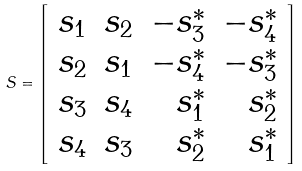Convert formula to latex. <formula><loc_0><loc_0><loc_500><loc_500>S = \left [ \begin{array} { c c r r } s _ { 1 } & s _ { 2 } & - s _ { 3 } ^ { * } & - s _ { 4 } ^ { * } \\ s _ { 2 } & s _ { 1 } & - s _ { 4 } ^ { * } & - s _ { 3 } ^ { * } \\ s _ { 3 } & s _ { 4 } & s _ { 1 } ^ { * } & s _ { 2 } ^ { * } \\ s _ { 4 } & s _ { 3 } & s _ { 2 } ^ { * } & s _ { 1 } ^ { * } \end{array} \right ]</formula> 